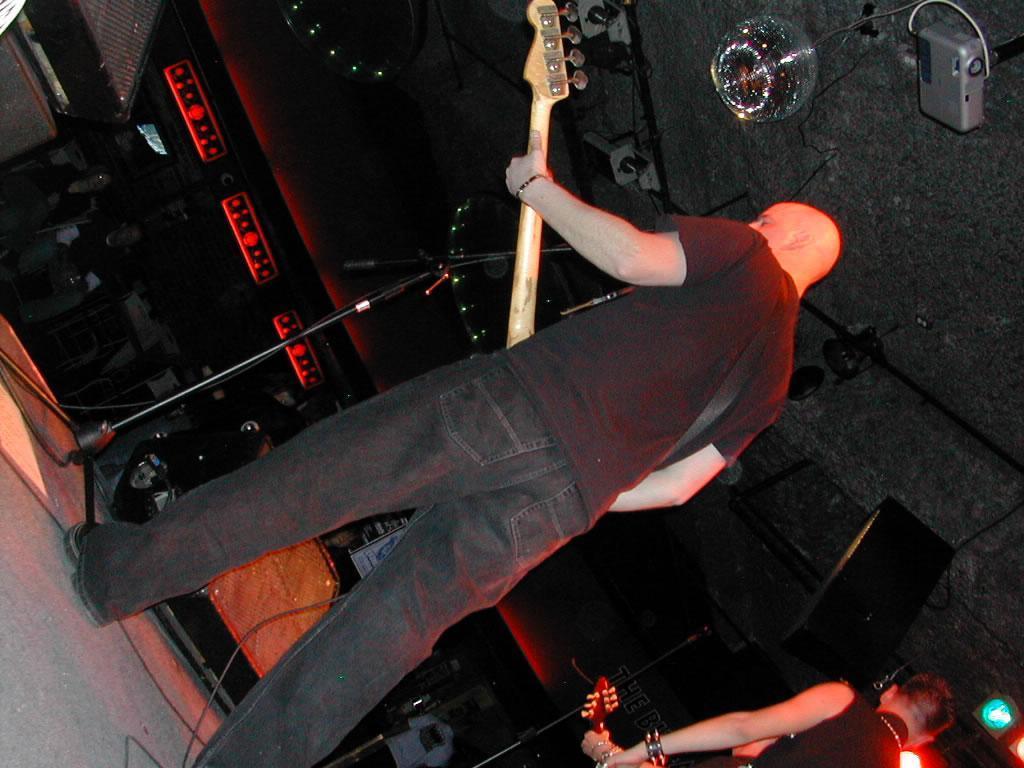Could you give a brief overview of what you see in this image? This image is clicked in a musical concert. There are two persons on the stage who are playing guitar. Both of them are wearing black shirts. Where are my eyes in front of them. There are lights in the bottom right corner. There are people on the left side who are watching them. 